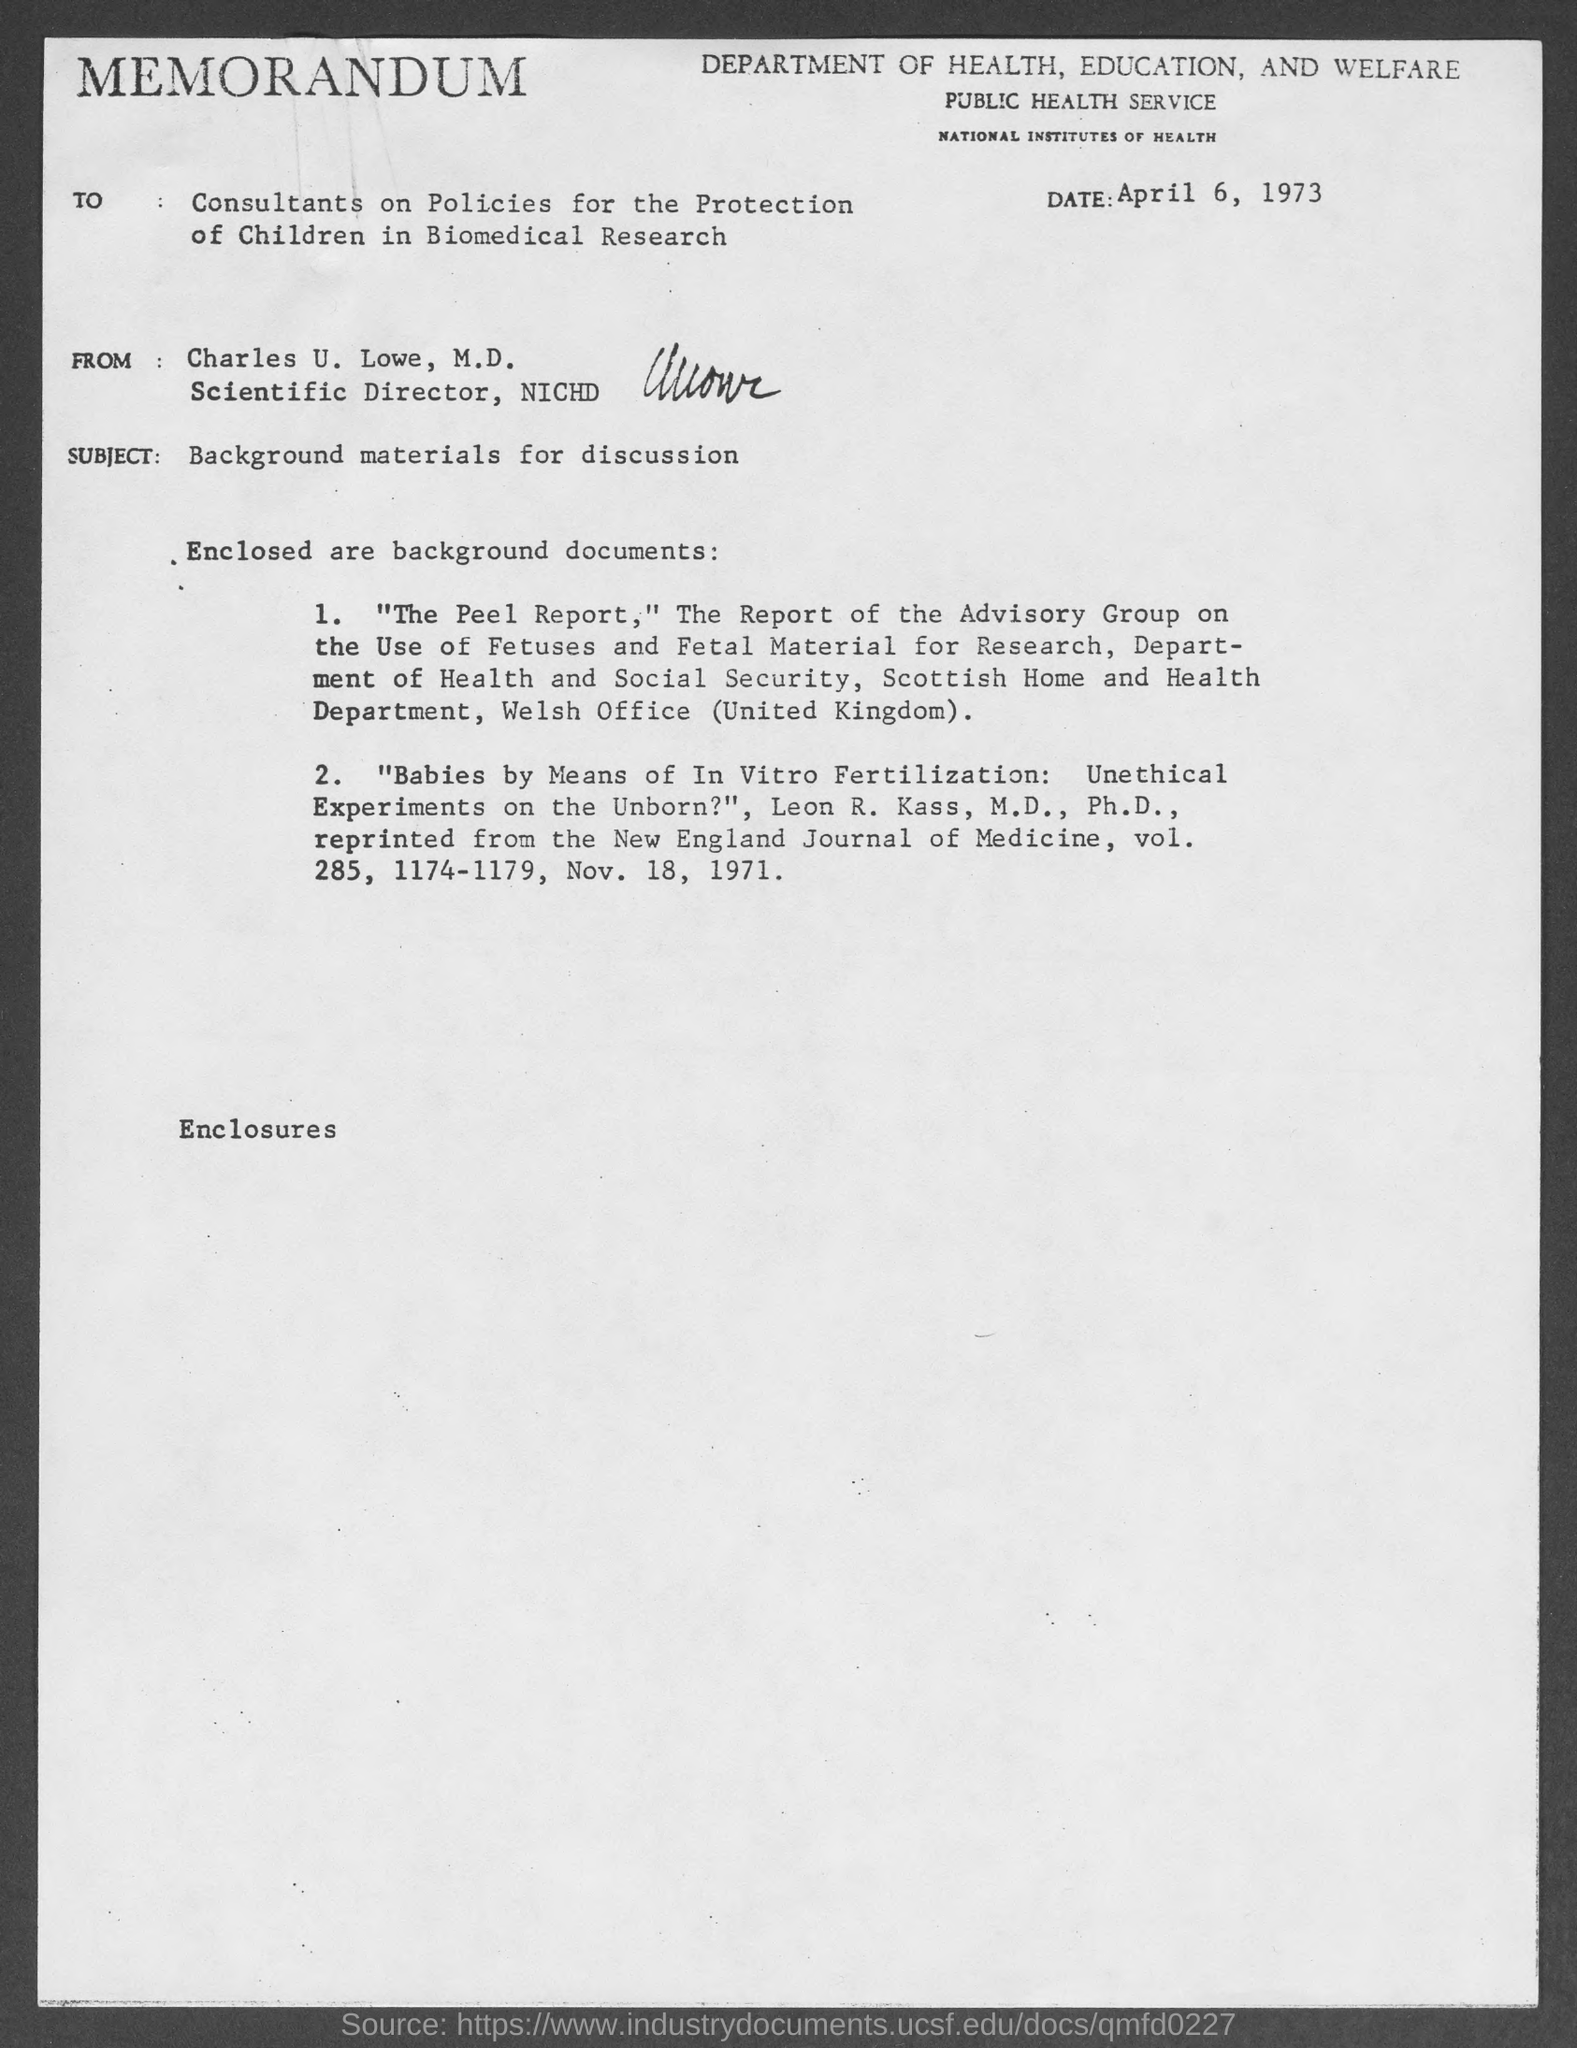Point out several critical features in this image. The date mentioned in the memorandum is April 6, 1973. The subject of this memorandum is the presentation of background materials for discussion. The memorandum states that the sender is Charles U. Lowe, M.D. 